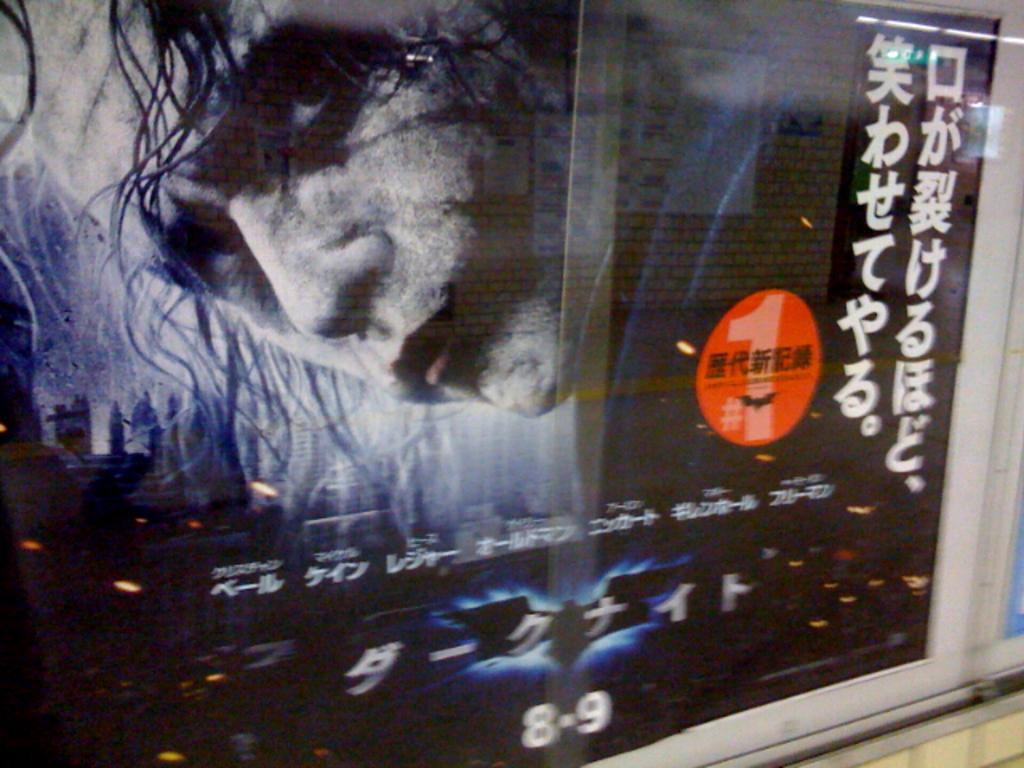<image>
Offer a succinct explanation of the picture presented. An advertisement for something that comes out on 8-9. 